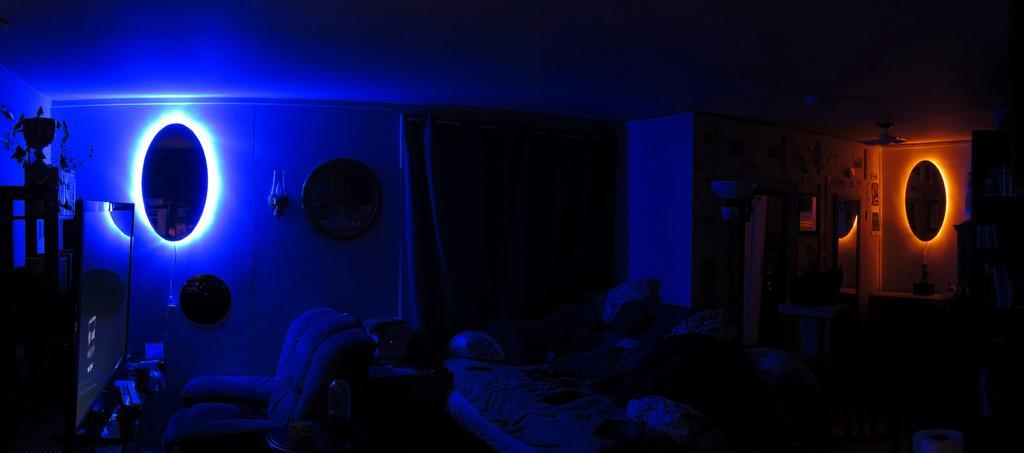Can you describe this image briefly? In this picture we can see a television, a chair, a mirror, a light and a trophy on the left side, there is a bed in the middle, it looks like a mirror on the right side, there is a dark background. 